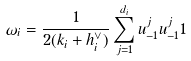Convert formula to latex. <formula><loc_0><loc_0><loc_500><loc_500>\omega _ { i } = \frac { 1 } { 2 ( k _ { i } + h _ { i } ^ { \vee } ) } \sum _ { j = 1 } ^ { d _ { i } } u ^ { j } _ { - 1 } u ^ { j } _ { - 1 } { 1 }</formula> 